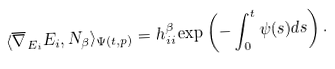<formula> <loc_0><loc_0><loc_500><loc_500>\langle \overline { \nabla } _ { E _ { i } } E _ { i } , N _ { \beta } \rangle _ { \Psi ( t , p ) } = h ^ { \beta } _ { i i } \exp \left ( - \int _ { 0 } ^ { t } \psi ( s ) d s \right ) .</formula> 